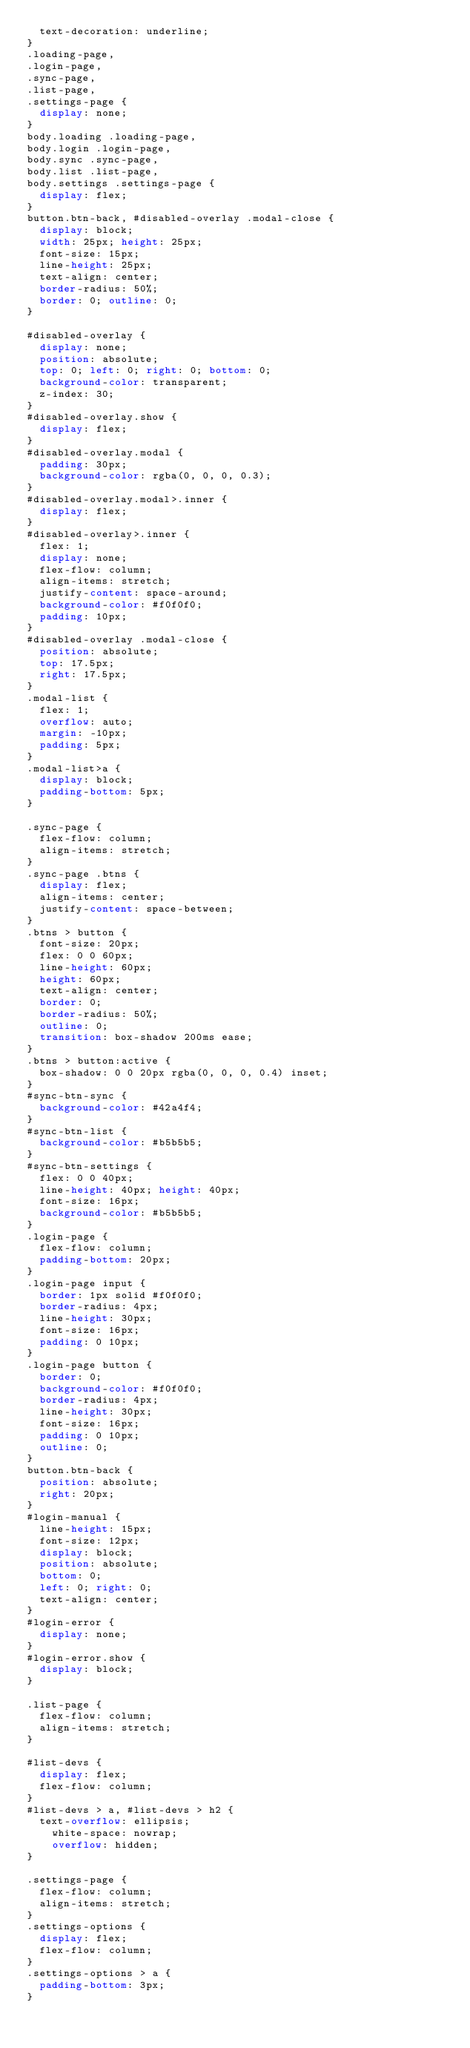<code> <loc_0><loc_0><loc_500><loc_500><_CSS_>	text-decoration: underline;
}
.loading-page,
.login-page,
.sync-page,
.list-page,
.settings-page {
	display: none;
}
body.loading .loading-page,
body.login .login-page,
body.sync .sync-page,
body.list .list-page,
body.settings .settings-page {
	display: flex;
}
button.btn-back, #disabled-overlay .modal-close {
	display: block;
	width: 25px; height: 25px;
	font-size: 15px;
	line-height: 25px;
	text-align: center;
	border-radius: 50%;
	border: 0; outline: 0;
}

#disabled-overlay {
	display: none;
	position: absolute;
	top: 0; left: 0; right: 0; bottom: 0;
	background-color: transparent;
	z-index: 30;
}
#disabled-overlay.show {
	display: flex;
}
#disabled-overlay.modal {
	padding: 30px;
	background-color: rgba(0, 0, 0, 0.3);
}
#disabled-overlay.modal>.inner {
	display: flex;
}
#disabled-overlay>.inner {
	flex: 1;
	display: none;
	flex-flow: column;
	align-items: stretch;
	justify-content: space-around;
	background-color: #f0f0f0;
	padding: 10px;
}
#disabled-overlay .modal-close {
	position: absolute;
	top: 17.5px;
	right: 17.5px;
}
.modal-list {
	flex: 1;
	overflow: auto;
	margin: -10px;
	padding: 5px;
}
.modal-list>a {
	display: block;
	padding-bottom: 5px;
}

.sync-page {
	flex-flow: column;
	align-items: stretch;
}
.sync-page .btns {
	display: flex;
	align-items: center;
	justify-content: space-between;
}
.btns > button {
	font-size: 20px;
	flex: 0 0 60px;
	line-height: 60px;
	height: 60px;
	text-align: center;
	border: 0;
	border-radius: 50%;
	outline: 0;
	transition: box-shadow 200ms ease;
}
.btns > button:active {
	box-shadow: 0 0 20px rgba(0, 0, 0, 0.4) inset;
}
#sync-btn-sync {
	background-color: #42a4f4;
}
#sync-btn-list {
	background-color: #b5b5b5;
}
#sync-btn-settings {
	flex: 0 0 40px;
	line-height: 40px; height: 40px;
	font-size: 16px;
	background-color: #b5b5b5;
}
.login-page {
	flex-flow: column;
	padding-bottom: 20px;
}
.login-page input {
	border: 1px solid #f0f0f0;
	border-radius: 4px;
	line-height: 30px;
	font-size: 16px;
	padding: 0 10px;
}
.login-page button {
	border: 0;
	background-color: #f0f0f0;
	border-radius: 4px;
	line-height: 30px;
	font-size: 16px;
	padding: 0 10px;
	outline: 0;
}
button.btn-back {
	position: absolute;
	right: 20px;
}
#login-manual {
	line-height: 15px;
	font-size: 12px;
	display: block;
	position: absolute;
	bottom: 0;
	left: 0; right: 0;
	text-align: center;
}
#login-error {
	display: none;
}
#login-error.show {
	display: block;
}

.list-page {
	flex-flow: column;
	align-items: stretch;
}

#list-devs {
	display: flex;
	flex-flow: column;
}
#list-devs > a, #list-devs > h2 {
	text-overflow: ellipsis;
    white-space: nowrap;
    overflow: hidden;
}

.settings-page {
	flex-flow: column;
	align-items: stretch;
}
.settings-options {
	display: flex;
	flex-flow: column;
}
.settings-options > a {
	padding-bottom: 3px;
}</code> 